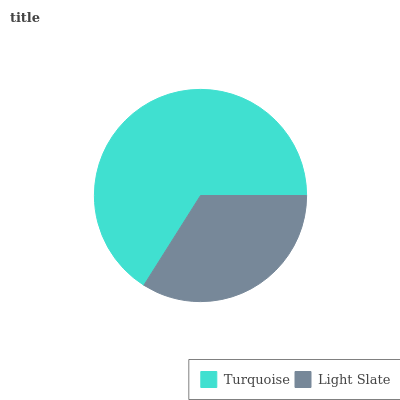Is Light Slate the minimum?
Answer yes or no. Yes. Is Turquoise the maximum?
Answer yes or no. Yes. Is Light Slate the maximum?
Answer yes or no. No. Is Turquoise greater than Light Slate?
Answer yes or no. Yes. Is Light Slate less than Turquoise?
Answer yes or no. Yes. Is Light Slate greater than Turquoise?
Answer yes or no. No. Is Turquoise less than Light Slate?
Answer yes or no. No. Is Turquoise the high median?
Answer yes or no. Yes. Is Light Slate the low median?
Answer yes or no. Yes. Is Light Slate the high median?
Answer yes or no. No. Is Turquoise the low median?
Answer yes or no. No. 